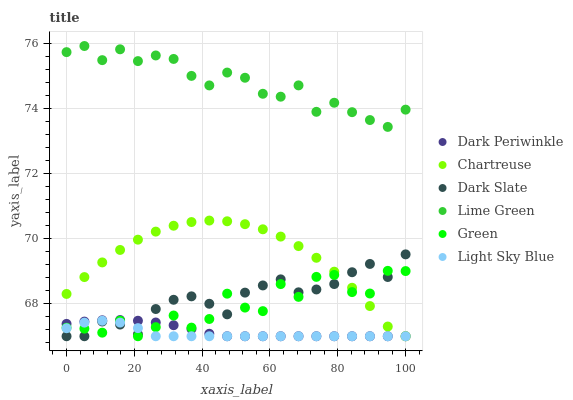Does Light Sky Blue have the minimum area under the curve?
Answer yes or no. Yes. Does Lime Green have the maximum area under the curve?
Answer yes or no. Yes. Does Chartreuse have the minimum area under the curve?
Answer yes or no. No. Does Chartreuse have the maximum area under the curve?
Answer yes or no. No. Is Dark Periwinkle the smoothest?
Answer yes or no. Yes. Is Green the roughest?
Answer yes or no. Yes. Is Chartreuse the smoothest?
Answer yes or no. No. Is Chartreuse the roughest?
Answer yes or no. No. Does Dark Slate have the lowest value?
Answer yes or no. Yes. Does Lime Green have the lowest value?
Answer yes or no. No. Does Lime Green have the highest value?
Answer yes or no. Yes. Does Chartreuse have the highest value?
Answer yes or no. No. Is Green less than Lime Green?
Answer yes or no. Yes. Is Lime Green greater than Dark Slate?
Answer yes or no. Yes. Does Dark Periwinkle intersect Light Sky Blue?
Answer yes or no. Yes. Is Dark Periwinkle less than Light Sky Blue?
Answer yes or no. No. Is Dark Periwinkle greater than Light Sky Blue?
Answer yes or no. No. Does Green intersect Lime Green?
Answer yes or no. No. 